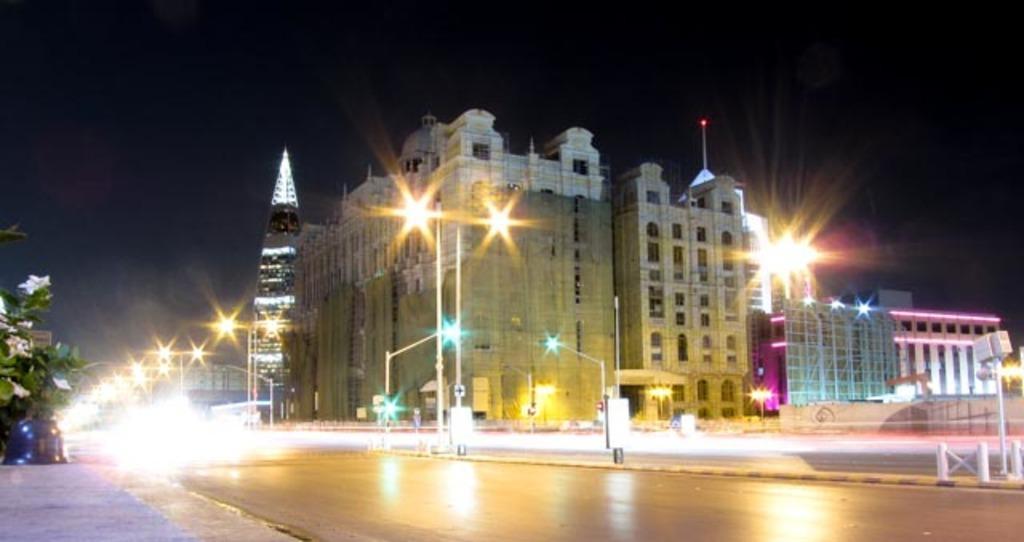Could you give a brief overview of what you see in this image? In this picture we can see view of the road. Behind there is a big building and some street lights. On the left side there is a small tree and many street lights on the road. 